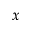Convert formula to latex. <formula><loc_0><loc_0><loc_500><loc_500>x</formula> 